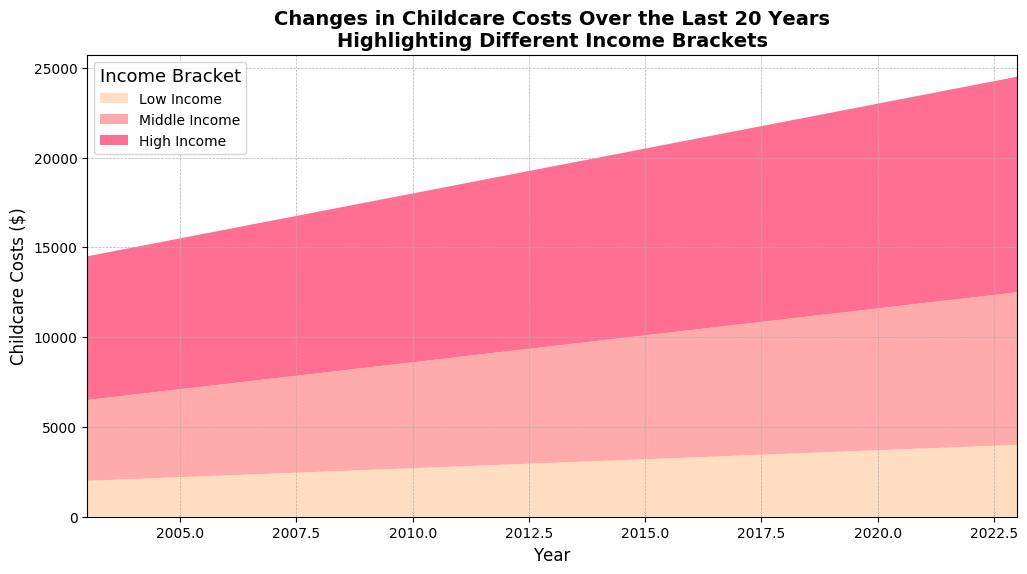How much did childcare costs for the high-income bracket increase from 2003 to 2023? The high-income bracket's childcare costs in 2003 were $8000. By 2023, these costs had risen to $12000. The increase can be calculated as $12000 - $8000 = $4000.
Answer: $4000 Which income bracket had the highest childcare costs in 2013? The areas representing different income brackets on the chart denote the relative costs. For 2013, the high-income bracket had the highest childcare costs at $10000.
Answer: High Income In which year did the middle-income bracket incur childcare costs of approximately $6700? By examining the middle-income section of the chart, we see that the middle-income bracket had childcare costs of around $6700 in 2014.
Answer: 2014 Compare the increase in childcare costs for the low-income bracket from 2003 to 2023 with the increase for the middle-income bracket over the same period. The low-income bracket's childcare costs rose from $2000 in 2003 to $4000 in 2023, an increase of $2000. The middle-income bracket's costs increased from $4500 in 2003 to $8500 in 2023, resulting in an increase of $4000.
Answer: The increase for low-income is $2000, and for middle-income is $4000 In which years did the childcare costs for all three income brackets show the same trend (either all increasing or all decreasing)? Reviewing the chart, it is clear that in every year from 2003 to 2023, the childcare costs for all three income brackets showed an increasing trend.
Answer: From 2003 to 2023 What's the average childcare cost for the middle-income bracket between 2003 and 2023? To find the average, sum the middle-income childcare costs from each year and divide by the number of years (21). The sum is $4500 (2003) + $4700 (2004) + $4900 (2005) + $5100 (2006) + $5300 (2007) + $5500 (2008) + $5700 (2009) + $5900 (2010) + $6100 (2011) + $6300 (2012) + $6500 (2013) + $6700 (2014) + $6900 (2015) + $7100 (2016) + $7300 (2017) + $7500 (2018) + $7700 (2019) + $7900 (2020) + $8100 (2021) + $8300 (2022) + $8500 (2023) = $147000. The average is $147000 / 21 ≈ $7000.
Answer: $7000 By how much did the low-income childcare costs change in the first decade (2003-2013)? In 2003, the low-income childcare costs were $2000. By 2013, they had increased to $3000. The change is $3000 - $2000 = $1000.
Answer: $1000 What color in the area chart represents the high-income bracket? The chart uses different colors to represent each income bracket. The high-income bracket is represented by the darkest color, which is a shade of pink.
Answer: Dark pink During which year did the childcare cost for the high-income bracket reach $11600? The childcare costs for the high-income bracket reach $11600 in the year 2021. This can be verified by checking the data at the peak closest to this value.
Answer: 2021 Which income bracket had the smallest increase in childcare costs from 2003 to 2023? By calculating the increases for each bracket: low-income increased by $2000, middle-income increased by $4000, and high-income increased by $4000. The low-income bracket had the smallest increase.
Answer: Low Income 